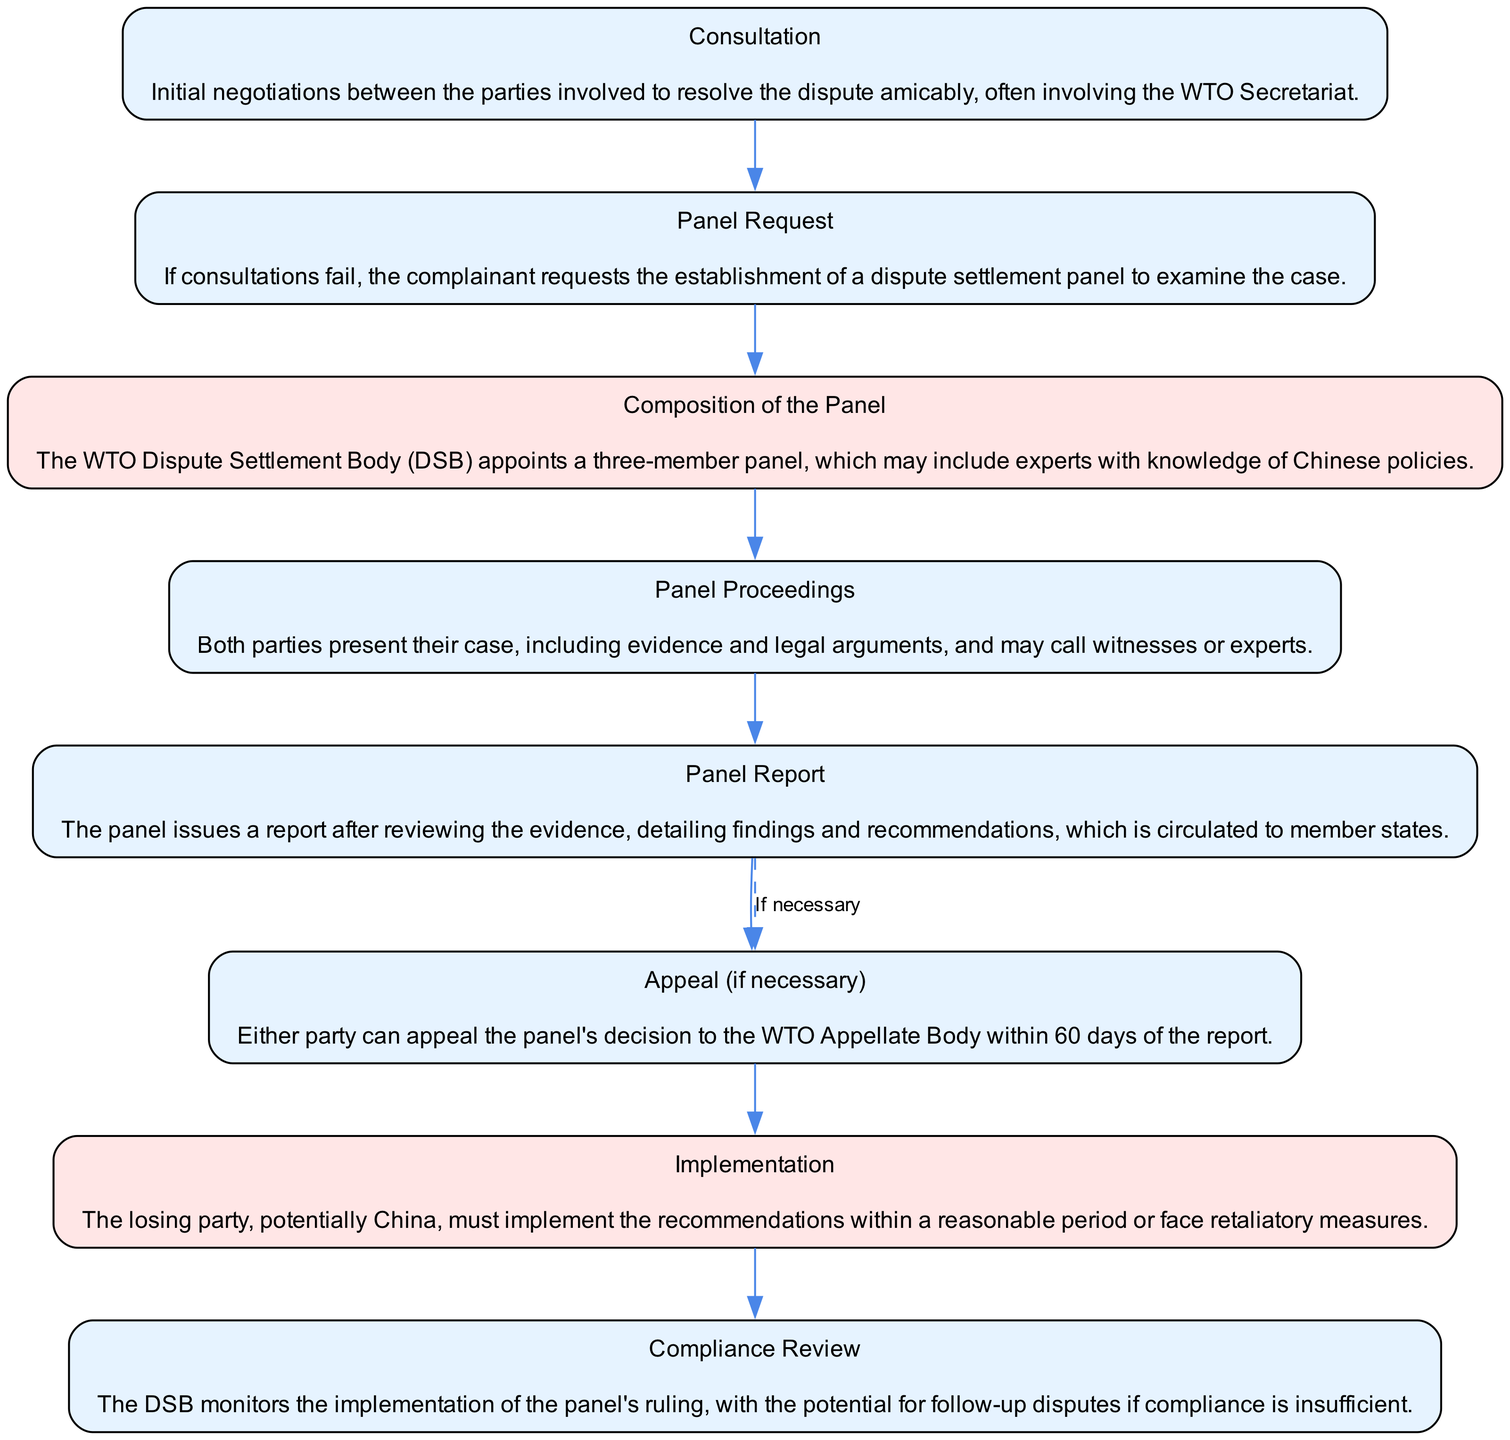What is the first step in the dispute resolution process? The first step in the diagram is "Consultation," which is the initial negotiation phase between the parties involved to resolve the dispute amicably.
Answer: Consultation How many steps are there in total? By counting the nodes in the diagram, there are a total of eight steps outlined in the dispute resolution process under the WTO.
Answer: 8 Which step involves the appeal process? The "Appeal (if necessary)" step specifically mentions the appeal process, indicating that either party can appeal the panel's decision.
Answer: Appeal (if necessary) What happens if consultations fail? If consultations fail, the complainant proceeds to the "Panel Request" step, where they request the establishment of a dispute settlement panel.
Answer: Panel Request What is highlighted in the diagram to indicate China's potential involvement? The steps "Composition of the Panel" and "Implementation" are highlighted to indicate China's potential involvement in the dispute resolution process.
Answer: Composition of the Panel, Implementation What is monitored during the compliance review step? During the "Compliance Review" step, the Dispute Settlement Body monitors the implementation of the panel's ruling.
Answer: Implementation of the panel's ruling What is the relationship between the "Panel Report" and the "Appeal"? The "Panel Report" is generated after the panel proceedings, and it has a dashed edge leading to the "Appeal (if necessary)" step, indicating that an appeal can occur based on the panel's decision.
Answer: The Panel Report leads to the Appeal step What must the losing party do after a dispute resolution? The losing party must implement the recommendations made in the panel report within a reasonable period to comply with the ruling.
Answer: Implement the recommendations 